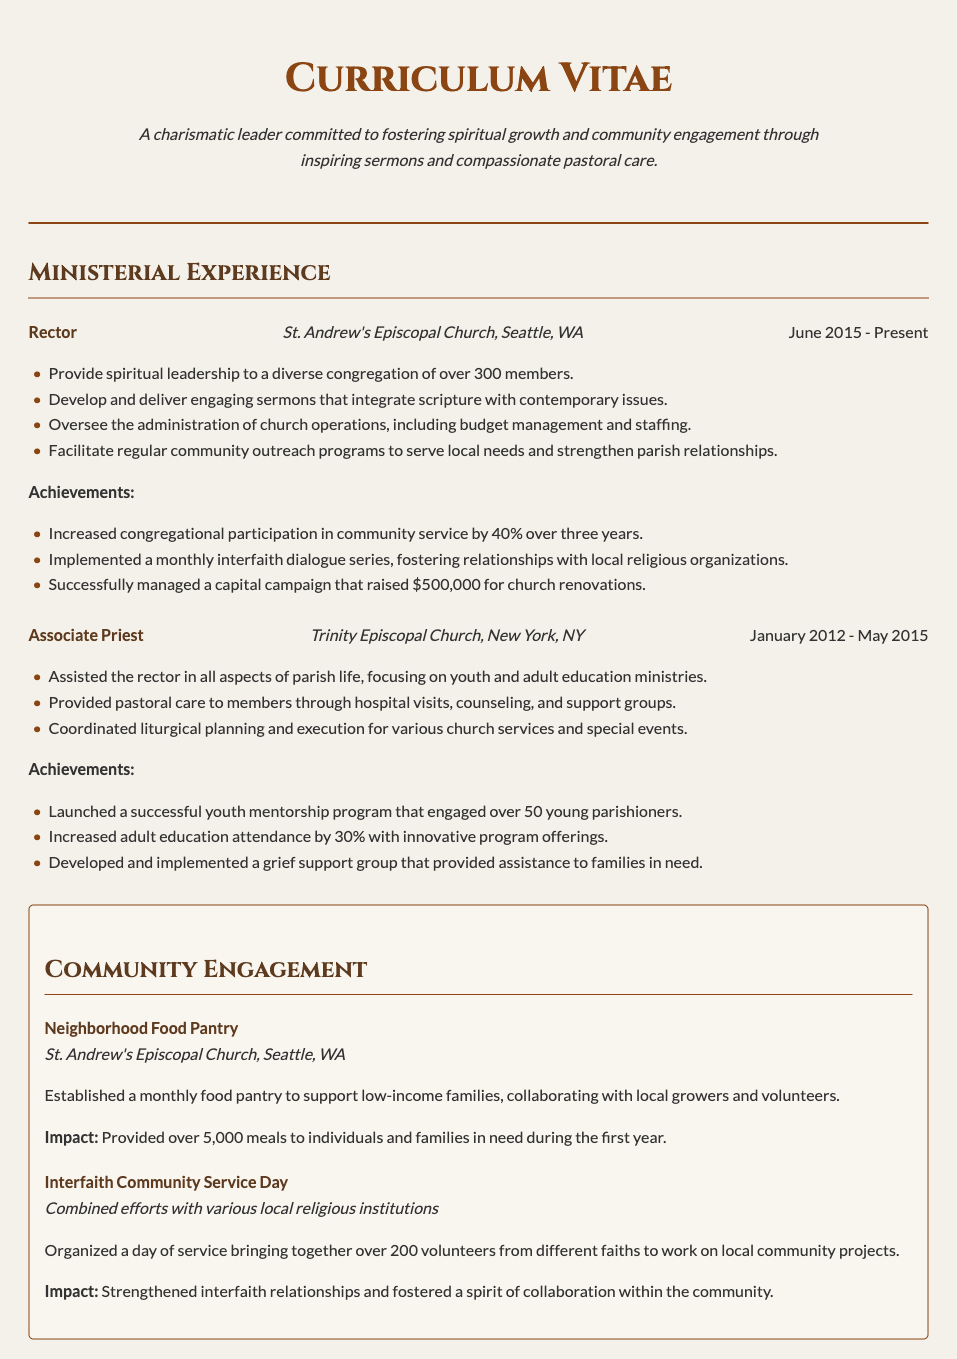What is the current position held? The current position mentioned in the CV is "Rector".
Answer: Rector Where is St. Andrew's Episcopal Church located? The CV specifies that St. Andrew's Episcopal Church is located in Seattle, WA.
Answer: Seattle, WA What was the percentage increase in community service participation over three years? The document states that congregational participation in community service increased by 40%.
Answer: 40% How many young parishioners engaged in the youth mentorship program? The CV mentions that the youth mentorship program engaged over 50 young parishioners.
Answer: over 50 What is the duration of the Associate Priest role? The role of Associate Priest lasted from January 2012 to May 2015.
Answer: January 2012 - May 2015 What type of community program was established at St. Andrew's Episcopal Church? The CV mentions the establishment of a "monthly food pantry".
Answer: monthly food pantry What was the total amount raised during the capital campaign? The document specifies that the capital campaign raised $500,000 for church renovations.
Answer: $500,000 How many volunteers participated in the Interfaith Community Service Day? The document states that over 200 volunteers participated in that event.
Answer: over 200 What achievement is associated with adult education attendance? The CV states that adult education attendance increased by 30%.
Answer: 30% 